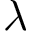<formula> <loc_0><loc_0><loc_500><loc_500>\lambda</formula> 